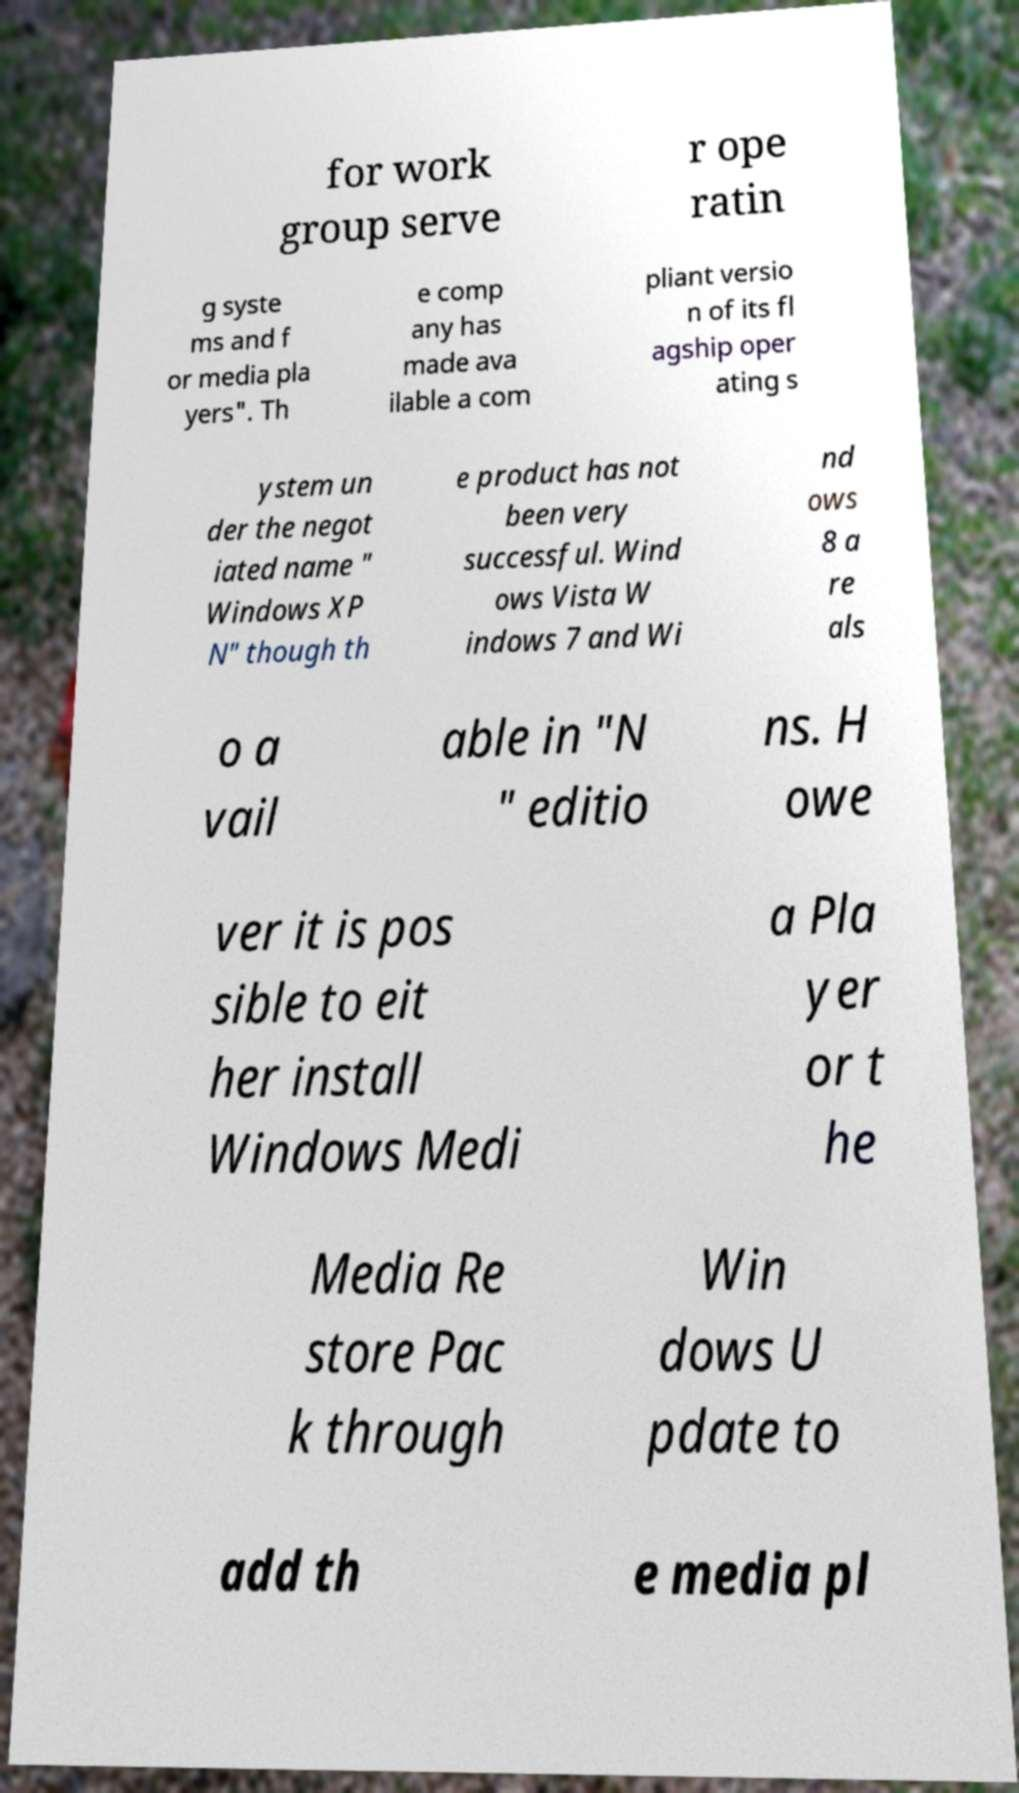Can you accurately transcribe the text from the provided image for me? for work group serve r ope ratin g syste ms and f or media pla yers". Th e comp any has made ava ilable a com pliant versio n of its fl agship oper ating s ystem un der the negot iated name " Windows XP N" though th e product has not been very successful. Wind ows Vista W indows 7 and Wi nd ows 8 a re als o a vail able in "N " editio ns. H owe ver it is pos sible to eit her install Windows Medi a Pla yer or t he Media Re store Pac k through Win dows U pdate to add th e media pl 